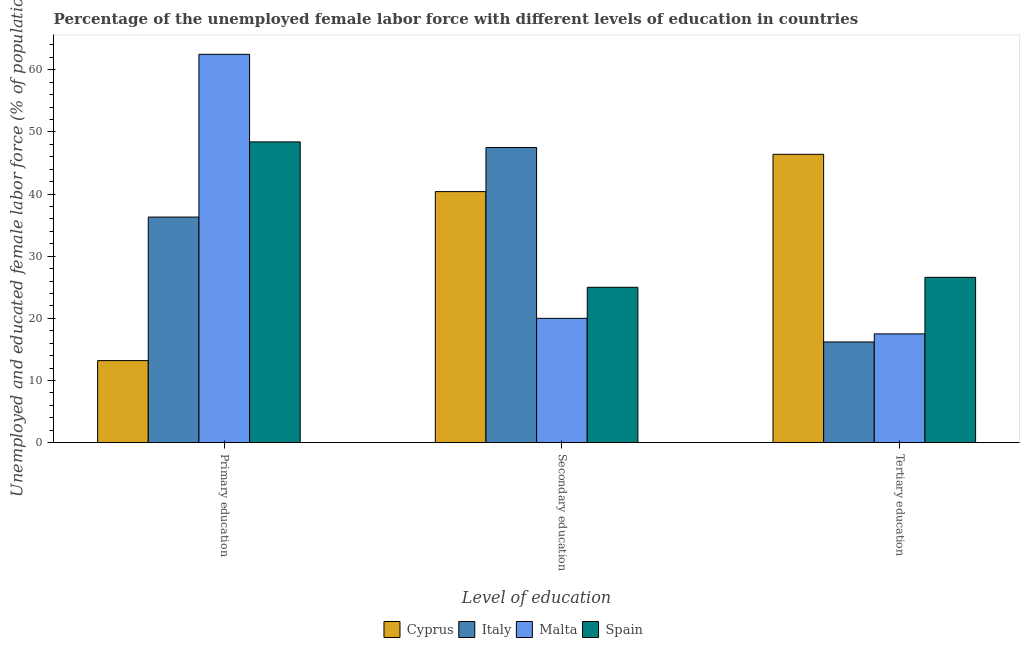Are the number of bars per tick equal to the number of legend labels?
Keep it short and to the point. Yes. Are the number of bars on each tick of the X-axis equal?
Ensure brevity in your answer.  Yes. How many bars are there on the 2nd tick from the right?
Offer a terse response. 4. What is the percentage of female labor force who received tertiary education in Spain?
Your answer should be very brief. 26.6. Across all countries, what is the maximum percentage of female labor force who received primary education?
Your response must be concise. 62.5. Across all countries, what is the minimum percentage of female labor force who received secondary education?
Offer a terse response. 20. In which country was the percentage of female labor force who received secondary education maximum?
Your answer should be compact. Italy. In which country was the percentage of female labor force who received primary education minimum?
Your answer should be very brief. Cyprus. What is the total percentage of female labor force who received tertiary education in the graph?
Provide a short and direct response. 106.7. What is the difference between the percentage of female labor force who received tertiary education in Italy and that in Cyprus?
Your response must be concise. -30.2. What is the difference between the percentage of female labor force who received secondary education in Spain and the percentage of female labor force who received primary education in Cyprus?
Your answer should be very brief. 11.8. What is the average percentage of female labor force who received tertiary education per country?
Offer a very short reply. 26.68. What is the difference between the percentage of female labor force who received primary education and percentage of female labor force who received secondary education in Malta?
Make the answer very short. 42.5. What is the ratio of the percentage of female labor force who received primary education in Spain to that in Italy?
Give a very brief answer. 1.33. Is the percentage of female labor force who received primary education in Cyprus less than that in Spain?
Ensure brevity in your answer.  Yes. Is the difference between the percentage of female labor force who received tertiary education in Spain and Italy greater than the difference between the percentage of female labor force who received primary education in Spain and Italy?
Your response must be concise. No. What is the difference between the highest and the second highest percentage of female labor force who received secondary education?
Your answer should be very brief. 7.1. What is the difference between the highest and the lowest percentage of female labor force who received primary education?
Your answer should be compact. 49.3. What does the 3rd bar from the left in Tertiary education represents?
Offer a terse response. Malta. What does the 2nd bar from the right in Secondary education represents?
Provide a succinct answer. Malta. How many bars are there?
Ensure brevity in your answer.  12. Are all the bars in the graph horizontal?
Ensure brevity in your answer.  No. How many countries are there in the graph?
Give a very brief answer. 4. What is the difference between two consecutive major ticks on the Y-axis?
Give a very brief answer. 10. Does the graph contain grids?
Keep it short and to the point. No. What is the title of the graph?
Your answer should be compact. Percentage of the unemployed female labor force with different levels of education in countries. What is the label or title of the X-axis?
Provide a short and direct response. Level of education. What is the label or title of the Y-axis?
Make the answer very short. Unemployed and educated female labor force (% of population). What is the Unemployed and educated female labor force (% of population) in Cyprus in Primary education?
Your answer should be very brief. 13.2. What is the Unemployed and educated female labor force (% of population) of Italy in Primary education?
Provide a short and direct response. 36.3. What is the Unemployed and educated female labor force (% of population) in Malta in Primary education?
Keep it short and to the point. 62.5. What is the Unemployed and educated female labor force (% of population) of Spain in Primary education?
Offer a terse response. 48.4. What is the Unemployed and educated female labor force (% of population) in Cyprus in Secondary education?
Give a very brief answer. 40.4. What is the Unemployed and educated female labor force (% of population) in Italy in Secondary education?
Make the answer very short. 47.5. What is the Unemployed and educated female labor force (% of population) of Cyprus in Tertiary education?
Provide a short and direct response. 46.4. What is the Unemployed and educated female labor force (% of population) of Italy in Tertiary education?
Your answer should be compact. 16.2. What is the Unemployed and educated female labor force (% of population) of Spain in Tertiary education?
Provide a succinct answer. 26.6. Across all Level of education, what is the maximum Unemployed and educated female labor force (% of population) in Cyprus?
Your answer should be compact. 46.4. Across all Level of education, what is the maximum Unemployed and educated female labor force (% of population) of Italy?
Your answer should be compact. 47.5. Across all Level of education, what is the maximum Unemployed and educated female labor force (% of population) of Malta?
Keep it short and to the point. 62.5. Across all Level of education, what is the maximum Unemployed and educated female labor force (% of population) of Spain?
Ensure brevity in your answer.  48.4. Across all Level of education, what is the minimum Unemployed and educated female labor force (% of population) in Cyprus?
Provide a short and direct response. 13.2. Across all Level of education, what is the minimum Unemployed and educated female labor force (% of population) of Italy?
Offer a very short reply. 16.2. Across all Level of education, what is the minimum Unemployed and educated female labor force (% of population) of Malta?
Provide a succinct answer. 17.5. What is the total Unemployed and educated female labor force (% of population) in Italy in the graph?
Your answer should be very brief. 100. What is the total Unemployed and educated female labor force (% of population) in Spain in the graph?
Offer a terse response. 100. What is the difference between the Unemployed and educated female labor force (% of population) in Cyprus in Primary education and that in Secondary education?
Provide a short and direct response. -27.2. What is the difference between the Unemployed and educated female labor force (% of population) in Malta in Primary education and that in Secondary education?
Your response must be concise. 42.5. What is the difference between the Unemployed and educated female labor force (% of population) of Spain in Primary education and that in Secondary education?
Provide a succinct answer. 23.4. What is the difference between the Unemployed and educated female labor force (% of population) in Cyprus in Primary education and that in Tertiary education?
Offer a very short reply. -33.2. What is the difference between the Unemployed and educated female labor force (% of population) in Italy in Primary education and that in Tertiary education?
Make the answer very short. 20.1. What is the difference between the Unemployed and educated female labor force (% of population) in Malta in Primary education and that in Tertiary education?
Provide a succinct answer. 45. What is the difference between the Unemployed and educated female labor force (% of population) in Spain in Primary education and that in Tertiary education?
Your response must be concise. 21.8. What is the difference between the Unemployed and educated female labor force (% of population) of Cyprus in Secondary education and that in Tertiary education?
Offer a terse response. -6. What is the difference between the Unemployed and educated female labor force (% of population) of Italy in Secondary education and that in Tertiary education?
Your response must be concise. 31.3. What is the difference between the Unemployed and educated female labor force (% of population) in Cyprus in Primary education and the Unemployed and educated female labor force (% of population) in Italy in Secondary education?
Offer a very short reply. -34.3. What is the difference between the Unemployed and educated female labor force (% of population) in Cyprus in Primary education and the Unemployed and educated female labor force (% of population) in Spain in Secondary education?
Offer a terse response. -11.8. What is the difference between the Unemployed and educated female labor force (% of population) of Malta in Primary education and the Unemployed and educated female labor force (% of population) of Spain in Secondary education?
Keep it short and to the point. 37.5. What is the difference between the Unemployed and educated female labor force (% of population) of Cyprus in Primary education and the Unemployed and educated female labor force (% of population) of Italy in Tertiary education?
Your response must be concise. -3. What is the difference between the Unemployed and educated female labor force (% of population) of Italy in Primary education and the Unemployed and educated female labor force (% of population) of Malta in Tertiary education?
Provide a succinct answer. 18.8. What is the difference between the Unemployed and educated female labor force (% of population) in Italy in Primary education and the Unemployed and educated female labor force (% of population) in Spain in Tertiary education?
Ensure brevity in your answer.  9.7. What is the difference between the Unemployed and educated female labor force (% of population) of Malta in Primary education and the Unemployed and educated female labor force (% of population) of Spain in Tertiary education?
Keep it short and to the point. 35.9. What is the difference between the Unemployed and educated female labor force (% of population) in Cyprus in Secondary education and the Unemployed and educated female labor force (% of population) in Italy in Tertiary education?
Offer a very short reply. 24.2. What is the difference between the Unemployed and educated female labor force (% of population) of Cyprus in Secondary education and the Unemployed and educated female labor force (% of population) of Malta in Tertiary education?
Ensure brevity in your answer.  22.9. What is the difference between the Unemployed and educated female labor force (% of population) in Cyprus in Secondary education and the Unemployed and educated female labor force (% of population) in Spain in Tertiary education?
Ensure brevity in your answer.  13.8. What is the difference between the Unemployed and educated female labor force (% of population) in Italy in Secondary education and the Unemployed and educated female labor force (% of population) in Malta in Tertiary education?
Provide a succinct answer. 30. What is the difference between the Unemployed and educated female labor force (% of population) in Italy in Secondary education and the Unemployed and educated female labor force (% of population) in Spain in Tertiary education?
Offer a very short reply. 20.9. What is the difference between the Unemployed and educated female labor force (% of population) of Malta in Secondary education and the Unemployed and educated female labor force (% of population) of Spain in Tertiary education?
Ensure brevity in your answer.  -6.6. What is the average Unemployed and educated female labor force (% of population) in Cyprus per Level of education?
Offer a terse response. 33.33. What is the average Unemployed and educated female labor force (% of population) in Italy per Level of education?
Your answer should be very brief. 33.33. What is the average Unemployed and educated female labor force (% of population) of Malta per Level of education?
Make the answer very short. 33.33. What is the average Unemployed and educated female labor force (% of population) of Spain per Level of education?
Provide a succinct answer. 33.33. What is the difference between the Unemployed and educated female labor force (% of population) in Cyprus and Unemployed and educated female labor force (% of population) in Italy in Primary education?
Keep it short and to the point. -23.1. What is the difference between the Unemployed and educated female labor force (% of population) in Cyprus and Unemployed and educated female labor force (% of population) in Malta in Primary education?
Offer a terse response. -49.3. What is the difference between the Unemployed and educated female labor force (% of population) of Cyprus and Unemployed and educated female labor force (% of population) of Spain in Primary education?
Your answer should be compact. -35.2. What is the difference between the Unemployed and educated female labor force (% of population) of Italy and Unemployed and educated female labor force (% of population) of Malta in Primary education?
Make the answer very short. -26.2. What is the difference between the Unemployed and educated female labor force (% of population) in Italy and Unemployed and educated female labor force (% of population) in Spain in Primary education?
Your response must be concise. -12.1. What is the difference between the Unemployed and educated female labor force (% of population) in Malta and Unemployed and educated female labor force (% of population) in Spain in Primary education?
Offer a very short reply. 14.1. What is the difference between the Unemployed and educated female labor force (% of population) in Cyprus and Unemployed and educated female labor force (% of population) in Malta in Secondary education?
Offer a terse response. 20.4. What is the difference between the Unemployed and educated female labor force (% of population) of Italy and Unemployed and educated female labor force (% of population) of Malta in Secondary education?
Provide a short and direct response. 27.5. What is the difference between the Unemployed and educated female labor force (% of population) of Italy and Unemployed and educated female labor force (% of population) of Spain in Secondary education?
Your response must be concise. 22.5. What is the difference between the Unemployed and educated female labor force (% of population) in Cyprus and Unemployed and educated female labor force (% of population) in Italy in Tertiary education?
Give a very brief answer. 30.2. What is the difference between the Unemployed and educated female labor force (% of population) of Cyprus and Unemployed and educated female labor force (% of population) of Malta in Tertiary education?
Provide a short and direct response. 28.9. What is the difference between the Unemployed and educated female labor force (% of population) of Cyprus and Unemployed and educated female labor force (% of population) of Spain in Tertiary education?
Keep it short and to the point. 19.8. What is the difference between the Unemployed and educated female labor force (% of population) of Italy and Unemployed and educated female labor force (% of population) of Malta in Tertiary education?
Provide a succinct answer. -1.3. What is the difference between the Unemployed and educated female labor force (% of population) of Malta and Unemployed and educated female labor force (% of population) of Spain in Tertiary education?
Your answer should be compact. -9.1. What is the ratio of the Unemployed and educated female labor force (% of population) of Cyprus in Primary education to that in Secondary education?
Ensure brevity in your answer.  0.33. What is the ratio of the Unemployed and educated female labor force (% of population) in Italy in Primary education to that in Secondary education?
Offer a terse response. 0.76. What is the ratio of the Unemployed and educated female labor force (% of population) of Malta in Primary education to that in Secondary education?
Offer a very short reply. 3.12. What is the ratio of the Unemployed and educated female labor force (% of population) in Spain in Primary education to that in Secondary education?
Ensure brevity in your answer.  1.94. What is the ratio of the Unemployed and educated female labor force (% of population) in Cyprus in Primary education to that in Tertiary education?
Ensure brevity in your answer.  0.28. What is the ratio of the Unemployed and educated female labor force (% of population) in Italy in Primary education to that in Tertiary education?
Your answer should be very brief. 2.24. What is the ratio of the Unemployed and educated female labor force (% of population) of Malta in Primary education to that in Tertiary education?
Your answer should be very brief. 3.57. What is the ratio of the Unemployed and educated female labor force (% of population) in Spain in Primary education to that in Tertiary education?
Give a very brief answer. 1.82. What is the ratio of the Unemployed and educated female labor force (% of population) of Cyprus in Secondary education to that in Tertiary education?
Provide a short and direct response. 0.87. What is the ratio of the Unemployed and educated female labor force (% of population) of Italy in Secondary education to that in Tertiary education?
Your response must be concise. 2.93. What is the ratio of the Unemployed and educated female labor force (% of population) in Malta in Secondary education to that in Tertiary education?
Your answer should be very brief. 1.14. What is the ratio of the Unemployed and educated female labor force (% of population) in Spain in Secondary education to that in Tertiary education?
Ensure brevity in your answer.  0.94. What is the difference between the highest and the second highest Unemployed and educated female labor force (% of population) of Cyprus?
Provide a succinct answer. 6. What is the difference between the highest and the second highest Unemployed and educated female labor force (% of population) in Malta?
Ensure brevity in your answer.  42.5. What is the difference between the highest and the second highest Unemployed and educated female labor force (% of population) in Spain?
Make the answer very short. 21.8. What is the difference between the highest and the lowest Unemployed and educated female labor force (% of population) of Cyprus?
Your answer should be very brief. 33.2. What is the difference between the highest and the lowest Unemployed and educated female labor force (% of population) in Italy?
Make the answer very short. 31.3. What is the difference between the highest and the lowest Unemployed and educated female labor force (% of population) in Malta?
Keep it short and to the point. 45. What is the difference between the highest and the lowest Unemployed and educated female labor force (% of population) of Spain?
Provide a short and direct response. 23.4. 